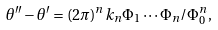Convert formula to latex. <formula><loc_0><loc_0><loc_500><loc_500>\theta ^ { \prime \prime } - \theta ^ { \prime } = ( 2 \pi ) ^ { n } k _ { n } \Phi _ { 1 } \cdots \Phi _ { n } / \Phi _ { 0 } ^ { n } ,</formula> 